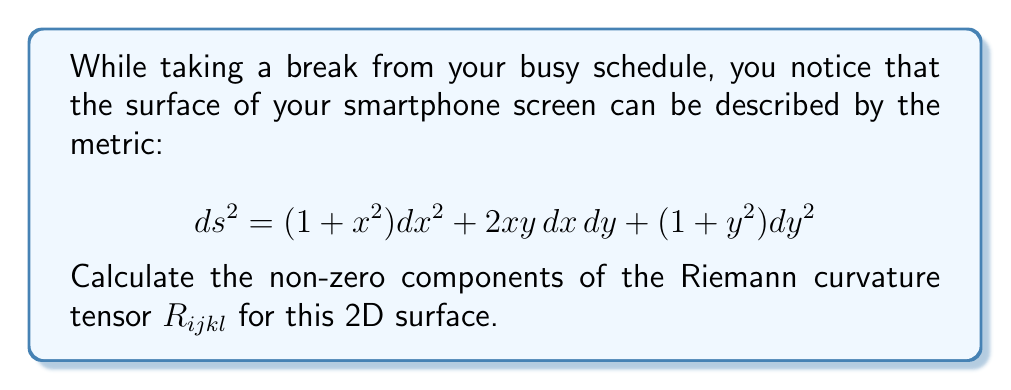Help me with this question. Let's approach this step-by-step:

1) First, we need to identify the metric components:
   $g_{11} = 1 + x^2$
   $g_{12} = g_{21} = xy$
   $g_{22} = 1 + y^2$

2) Calculate the inverse metric:
   $$ \det(g) = (1+x^2)(1+y^2) - (xy)^2 $$
   $g^{11} = \frac{1+y^2}{\det(g)}$
   $g^{12} = g^{21} = \frac{-xy}{\det(g)}$
   $g^{22} = \frac{1+x^2}{\det(g)}$

3) Calculate the Christoffel symbols:
   $\Gamma^i_{jk} = \frac{1}{2}g^{im}(\partial_j g_{mk} + \partial_k g_{jm} - \partial_m g_{jk})$

   Key non-zero components:
   $\Gamma^1_{11} = \frac{x}{1+x^2}$
   $\Gamma^1_{12} = \Gamma^1_{21} = \frac{y}{1+x^2}$
   $\Gamma^2_{12} = \Gamma^2_{21} = \frac{x}{1+y^2}$
   $\Gamma^2_{22} = \frac{y}{1+y^2}$

4) The Riemann curvature tensor is given by:
   $R^i_{jkl} = \partial_k \Gamma^i_{jl} - \partial_l \Gamma^i_{jk} + \Gamma^m_{jl}\Gamma^i_{mk} - \Gamma^m_{jk}\Gamma^i_{ml}$

5) Calculate the non-zero components:
   $R^1_{212} = -R^1_{221} = \partial_1 \Gamma^1_{22} - \partial_2 \Gamma^1_{21} + \Gamma^1_{21}\Gamma^1_{12} + \Gamma^2_{21}\Gamma^1_{22} - \Gamma^1_{22}\Gamma^1_{11} - \Gamma^2_{22}\Gamma^1_{21}$
   
   $R^2_{121} = -R^2_{112} = \partial_1 \Gamma^2_{21} - \partial_2 \Gamma^2_{11} + \Gamma^1_{21}\Gamma^2_{11} + \Gamma^2_{21}\Gamma^2_{21} - \Gamma^1_{11}\Gamma^2_{21} - \Gamma^2_{11}\Gamma^2_{22}$

6) After simplification:
   $R^1_{212} = -R^1_{221} = \frac{1}{(1+x^2)^2(1+y^2)}$
   $R^2_{121} = -R^2_{112} = \frac{1}{(1+x^2)(1+y^2)^2}$

7) Lower the indices using the metric:
   $R_{1212} = g_{1m}R^m_{212} = (1+x^2)R^1_{212} + xyR^2_{212} = \frac{1}{1+y^2}$
Answer: $R_{1212} = \frac{1}{1+y^2}$ 